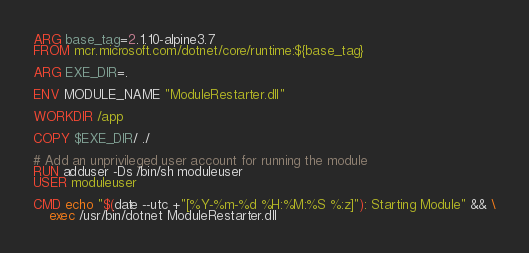<code> <loc_0><loc_0><loc_500><loc_500><_Dockerfile_>ARG base_tag=2.1.10-alpine3.7
FROM mcr.microsoft.com/dotnet/core/runtime:${base_tag}

ARG EXE_DIR=.

ENV MODULE_NAME "ModuleRestarter.dll"

WORKDIR /app

COPY $EXE_DIR/ ./

# Add an unprivileged user account for running the module
RUN adduser -Ds /bin/sh moduleuser 
USER moduleuser

CMD echo "$(date --utc +"[%Y-%m-%d %H:%M:%S %:z]"): Starting Module" && \
    exec /usr/bin/dotnet ModuleRestarter.dll
</code> 